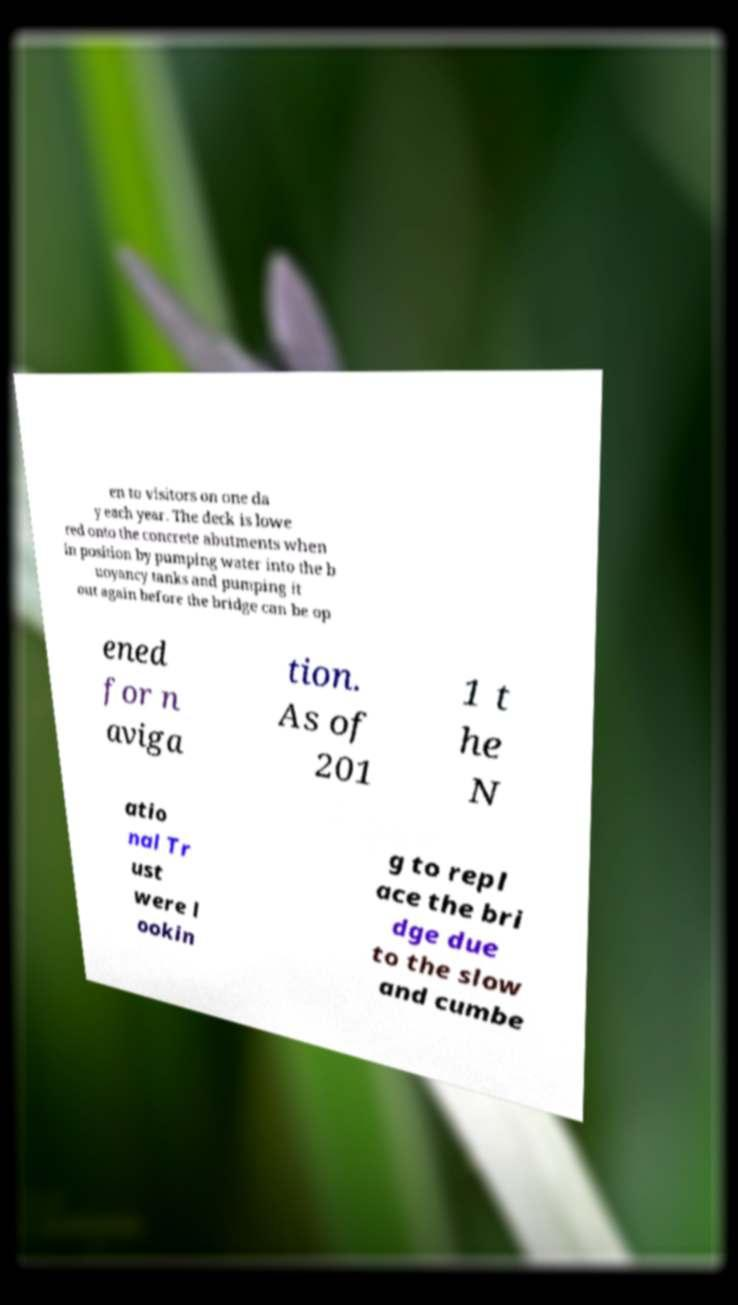Can you read and provide the text displayed in the image?This photo seems to have some interesting text. Can you extract and type it out for me? en to visitors on one da y each year. The deck is lowe red onto the concrete abutments when in position by pumping water into the b uoyancy tanks and pumping it out again before the bridge can be op ened for n aviga tion. As of 201 1 t he N atio nal Tr ust were l ookin g to repl ace the bri dge due to the slow and cumbe 